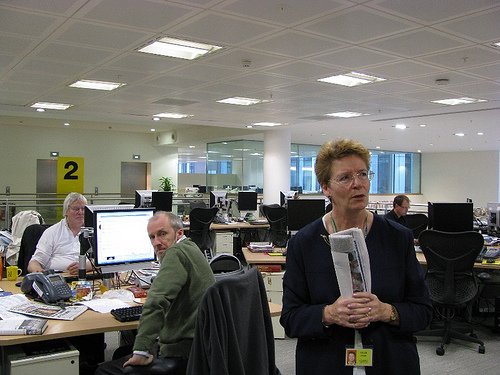<image>
Can you confirm if the monitor is behind the man? Yes. From this viewpoint, the monitor is positioned behind the man, with the man partially or fully occluding the monitor. 